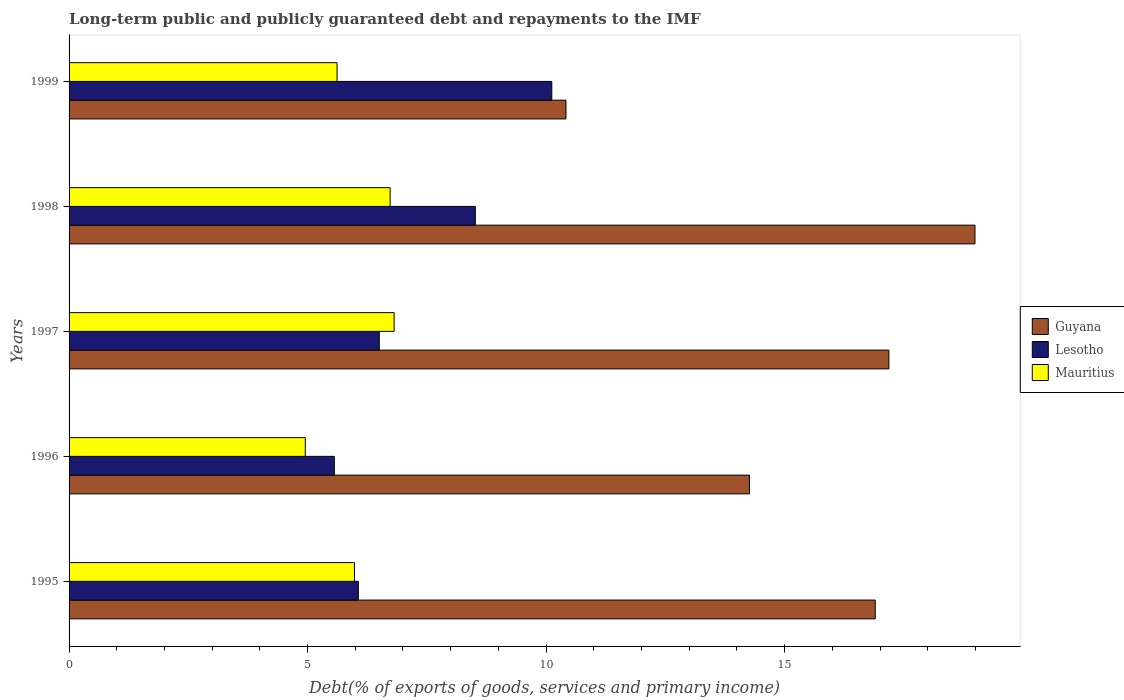How many different coloured bars are there?
Your answer should be very brief. 3. How many groups of bars are there?
Provide a short and direct response. 5. Are the number of bars per tick equal to the number of legend labels?
Your answer should be very brief. Yes. Are the number of bars on each tick of the Y-axis equal?
Make the answer very short. Yes. How many bars are there on the 5th tick from the bottom?
Provide a short and direct response. 3. In how many cases, is the number of bars for a given year not equal to the number of legend labels?
Your answer should be compact. 0. What is the debt and repayments in Guyana in 1999?
Offer a very short reply. 10.42. Across all years, what is the maximum debt and repayments in Guyana?
Your answer should be very brief. 18.99. Across all years, what is the minimum debt and repayments in Lesotho?
Offer a terse response. 5.56. What is the total debt and repayments in Lesotho in the graph?
Your answer should be compact. 36.76. What is the difference between the debt and repayments in Guyana in 1996 and that in 1998?
Ensure brevity in your answer.  -4.73. What is the difference between the debt and repayments in Mauritius in 1995 and the debt and repayments in Guyana in 1998?
Give a very brief answer. -13.01. What is the average debt and repayments in Guyana per year?
Your response must be concise. 15.55. In the year 1997, what is the difference between the debt and repayments in Mauritius and debt and repayments in Guyana?
Offer a very short reply. -10.37. What is the ratio of the debt and repayments in Guyana in 1995 to that in 1999?
Give a very brief answer. 1.62. What is the difference between the highest and the second highest debt and repayments in Lesotho?
Keep it short and to the point. 1.6. What is the difference between the highest and the lowest debt and repayments in Lesotho?
Ensure brevity in your answer.  4.56. Is the sum of the debt and repayments in Mauritius in 1998 and 1999 greater than the maximum debt and repayments in Guyana across all years?
Your answer should be very brief. No. What does the 2nd bar from the top in 1996 represents?
Your answer should be compact. Lesotho. What does the 1st bar from the bottom in 1998 represents?
Offer a terse response. Guyana. Are all the bars in the graph horizontal?
Make the answer very short. Yes. Does the graph contain any zero values?
Your answer should be compact. No. How many legend labels are there?
Give a very brief answer. 3. What is the title of the graph?
Ensure brevity in your answer.  Long-term public and publicly guaranteed debt and repayments to the IMF. Does "Kosovo" appear as one of the legend labels in the graph?
Provide a succinct answer. No. What is the label or title of the X-axis?
Ensure brevity in your answer.  Debt(% of exports of goods, services and primary income). What is the Debt(% of exports of goods, services and primary income) in Guyana in 1995?
Make the answer very short. 16.9. What is the Debt(% of exports of goods, services and primary income) of Lesotho in 1995?
Your response must be concise. 6.06. What is the Debt(% of exports of goods, services and primary income) of Mauritius in 1995?
Offer a terse response. 5.98. What is the Debt(% of exports of goods, services and primary income) in Guyana in 1996?
Give a very brief answer. 14.26. What is the Debt(% of exports of goods, services and primary income) of Lesotho in 1996?
Your response must be concise. 5.56. What is the Debt(% of exports of goods, services and primary income) of Mauritius in 1996?
Keep it short and to the point. 4.95. What is the Debt(% of exports of goods, services and primary income) in Guyana in 1997?
Keep it short and to the point. 17.19. What is the Debt(% of exports of goods, services and primary income) of Lesotho in 1997?
Provide a short and direct response. 6.5. What is the Debt(% of exports of goods, services and primary income) in Mauritius in 1997?
Ensure brevity in your answer.  6.81. What is the Debt(% of exports of goods, services and primary income) in Guyana in 1998?
Give a very brief answer. 18.99. What is the Debt(% of exports of goods, services and primary income) of Lesotho in 1998?
Provide a succinct answer. 8.52. What is the Debt(% of exports of goods, services and primary income) in Mauritius in 1998?
Provide a succinct answer. 6.73. What is the Debt(% of exports of goods, services and primary income) of Guyana in 1999?
Your response must be concise. 10.42. What is the Debt(% of exports of goods, services and primary income) in Lesotho in 1999?
Provide a succinct answer. 10.12. What is the Debt(% of exports of goods, services and primary income) of Mauritius in 1999?
Your answer should be compact. 5.62. Across all years, what is the maximum Debt(% of exports of goods, services and primary income) in Guyana?
Provide a short and direct response. 18.99. Across all years, what is the maximum Debt(% of exports of goods, services and primary income) of Lesotho?
Provide a succinct answer. 10.12. Across all years, what is the maximum Debt(% of exports of goods, services and primary income) in Mauritius?
Provide a short and direct response. 6.81. Across all years, what is the minimum Debt(% of exports of goods, services and primary income) in Guyana?
Offer a terse response. 10.42. Across all years, what is the minimum Debt(% of exports of goods, services and primary income) of Lesotho?
Provide a short and direct response. 5.56. Across all years, what is the minimum Debt(% of exports of goods, services and primary income) of Mauritius?
Give a very brief answer. 4.95. What is the total Debt(% of exports of goods, services and primary income) of Guyana in the graph?
Make the answer very short. 77.76. What is the total Debt(% of exports of goods, services and primary income) in Lesotho in the graph?
Make the answer very short. 36.76. What is the total Debt(% of exports of goods, services and primary income) of Mauritius in the graph?
Your answer should be very brief. 30.1. What is the difference between the Debt(% of exports of goods, services and primary income) of Guyana in 1995 and that in 1996?
Offer a very short reply. 2.64. What is the difference between the Debt(% of exports of goods, services and primary income) of Lesotho in 1995 and that in 1996?
Keep it short and to the point. 0.5. What is the difference between the Debt(% of exports of goods, services and primary income) in Mauritius in 1995 and that in 1996?
Offer a very short reply. 1.03. What is the difference between the Debt(% of exports of goods, services and primary income) of Guyana in 1995 and that in 1997?
Provide a succinct answer. -0.29. What is the difference between the Debt(% of exports of goods, services and primary income) of Lesotho in 1995 and that in 1997?
Make the answer very short. -0.44. What is the difference between the Debt(% of exports of goods, services and primary income) in Mauritius in 1995 and that in 1997?
Your answer should be compact. -0.83. What is the difference between the Debt(% of exports of goods, services and primary income) in Guyana in 1995 and that in 1998?
Keep it short and to the point. -2.09. What is the difference between the Debt(% of exports of goods, services and primary income) of Lesotho in 1995 and that in 1998?
Keep it short and to the point. -2.45. What is the difference between the Debt(% of exports of goods, services and primary income) in Mauritius in 1995 and that in 1998?
Provide a succinct answer. -0.75. What is the difference between the Debt(% of exports of goods, services and primary income) in Guyana in 1995 and that in 1999?
Provide a succinct answer. 6.48. What is the difference between the Debt(% of exports of goods, services and primary income) of Lesotho in 1995 and that in 1999?
Your response must be concise. -4.06. What is the difference between the Debt(% of exports of goods, services and primary income) of Mauritius in 1995 and that in 1999?
Provide a succinct answer. 0.36. What is the difference between the Debt(% of exports of goods, services and primary income) of Guyana in 1996 and that in 1997?
Offer a terse response. -2.92. What is the difference between the Debt(% of exports of goods, services and primary income) of Lesotho in 1996 and that in 1997?
Your answer should be compact. -0.94. What is the difference between the Debt(% of exports of goods, services and primary income) of Mauritius in 1996 and that in 1997?
Make the answer very short. -1.86. What is the difference between the Debt(% of exports of goods, services and primary income) of Guyana in 1996 and that in 1998?
Provide a succinct answer. -4.73. What is the difference between the Debt(% of exports of goods, services and primary income) of Lesotho in 1996 and that in 1998?
Offer a terse response. -2.96. What is the difference between the Debt(% of exports of goods, services and primary income) of Mauritius in 1996 and that in 1998?
Give a very brief answer. -1.78. What is the difference between the Debt(% of exports of goods, services and primary income) in Guyana in 1996 and that in 1999?
Your answer should be very brief. 3.85. What is the difference between the Debt(% of exports of goods, services and primary income) in Lesotho in 1996 and that in 1999?
Keep it short and to the point. -4.56. What is the difference between the Debt(% of exports of goods, services and primary income) in Mauritius in 1996 and that in 1999?
Ensure brevity in your answer.  -0.67. What is the difference between the Debt(% of exports of goods, services and primary income) in Guyana in 1997 and that in 1998?
Your answer should be compact. -1.8. What is the difference between the Debt(% of exports of goods, services and primary income) of Lesotho in 1997 and that in 1998?
Provide a short and direct response. -2.01. What is the difference between the Debt(% of exports of goods, services and primary income) of Mauritius in 1997 and that in 1998?
Ensure brevity in your answer.  0.08. What is the difference between the Debt(% of exports of goods, services and primary income) of Guyana in 1997 and that in 1999?
Make the answer very short. 6.77. What is the difference between the Debt(% of exports of goods, services and primary income) of Lesotho in 1997 and that in 1999?
Provide a succinct answer. -3.62. What is the difference between the Debt(% of exports of goods, services and primary income) in Mauritius in 1997 and that in 1999?
Offer a terse response. 1.2. What is the difference between the Debt(% of exports of goods, services and primary income) in Guyana in 1998 and that in 1999?
Provide a succinct answer. 8.57. What is the difference between the Debt(% of exports of goods, services and primary income) of Lesotho in 1998 and that in 1999?
Provide a short and direct response. -1.6. What is the difference between the Debt(% of exports of goods, services and primary income) of Mauritius in 1998 and that in 1999?
Offer a very short reply. 1.11. What is the difference between the Debt(% of exports of goods, services and primary income) of Guyana in 1995 and the Debt(% of exports of goods, services and primary income) of Lesotho in 1996?
Ensure brevity in your answer.  11.34. What is the difference between the Debt(% of exports of goods, services and primary income) of Guyana in 1995 and the Debt(% of exports of goods, services and primary income) of Mauritius in 1996?
Your answer should be compact. 11.95. What is the difference between the Debt(% of exports of goods, services and primary income) of Lesotho in 1995 and the Debt(% of exports of goods, services and primary income) of Mauritius in 1996?
Make the answer very short. 1.11. What is the difference between the Debt(% of exports of goods, services and primary income) of Guyana in 1995 and the Debt(% of exports of goods, services and primary income) of Lesotho in 1997?
Your answer should be compact. 10.4. What is the difference between the Debt(% of exports of goods, services and primary income) in Guyana in 1995 and the Debt(% of exports of goods, services and primary income) in Mauritius in 1997?
Offer a very short reply. 10.09. What is the difference between the Debt(% of exports of goods, services and primary income) of Lesotho in 1995 and the Debt(% of exports of goods, services and primary income) of Mauritius in 1997?
Your answer should be very brief. -0.75. What is the difference between the Debt(% of exports of goods, services and primary income) of Guyana in 1995 and the Debt(% of exports of goods, services and primary income) of Lesotho in 1998?
Make the answer very short. 8.38. What is the difference between the Debt(% of exports of goods, services and primary income) of Guyana in 1995 and the Debt(% of exports of goods, services and primary income) of Mauritius in 1998?
Offer a terse response. 10.17. What is the difference between the Debt(% of exports of goods, services and primary income) in Guyana in 1995 and the Debt(% of exports of goods, services and primary income) in Lesotho in 1999?
Provide a succinct answer. 6.78. What is the difference between the Debt(% of exports of goods, services and primary income) in Guyana in 1995 and the Debt(% of exports of goods, services and primary income) in Mauritius in 1999?
Give a very brief answer. 11.28. What is the difference between the Debt(% of exports of goods, services and primary income) of Lesotho in 1995 and the Debt(% of exports of goods, services and primary income) of Mauritius in 1999?
Keep it short and to the point. 0.45. What is the difference between the Debt(% of exports of goods, services and primary income) of Guyana in 1996 and the Debt(% of exports of goods, services and primary income) of Lesotho in 1997?
Your answer should be compact. 7.76. What is the difference between the Debt(% of exports of goods, services and primary income) in Guyana in 1996 and the Debt(% of exports of goods, services and primary income) in Mauritius in 1997?
Ensure brevity in your answer.  7.45. What is the difference between the Debt(% of exports of goods, services and primary income) in Lesotho in 1996 and the Debt(% of exports of goods, services and primary income) in Mauritius in 1997?
Make the answer very short. -1.25. What is the difference between the Debt(% of exports of goods, services and primary income) in Guyana in 1996 and the Debt(% of exports of goods, services and primary income) in Lesotho in 1998?
Keep it short and to the point. 5.75. What is the difference between the Debt(% of exports of goods, services and primary income) in Guyana in 1996 and the Debt(% of exports of goods, services and primary income) in Mauritius in 1998?
Ensure brevity in your answer.  7.53. What is the difference between the Debt(% of exports of goods, services and primary income) in Lesotho in 1996 and the Debt(% of exports of goods, services and primary income) in Mauritius in 1998?
Ensure brevity in your answer.  -1.17. What is the difference between the Debt(% of exports of goods, services and primary income) in Guyana in 1996 and the Debt(% of exports of goods, services and primary income) in Lesotho in 1999?
Your response must be concise. 4.14. What is the difference between the Debt(% of exports of goods, services and primary income) of Guyana in 1996 and the Debt(% of exports of goods, services and primary income) of Mauritius in 1999?
Provide a succinct answer. 8.65. What is the difference between the Debt(% of exports of goods, services and primary income) in Lesotho in 1996 and the Debt(% of exports of goods, services and primary income) in Mauritius in 1999?
Provide a succinct answer. -0.06. What is the difference between the Debt(% of exports of goods, services and primary income) in Guyana in 1997 and the Debt(% of exports of goods, services and primary income) in Lesotho in 1998?
Offer a very short reply. 8.67. What is the difference between the Debt(% of exports of goods, services and primary income) in Guyana in 1997 and the Debt(% of exports of goods, services and primary income) in Mauritius in 1998?
Your response must be concise. 10.46. What is the difference between the Debt(% of exports of goods, services and primary income) of Lesotho in 1997 and the Debt(% of exports of goods, services and primary income) of Mauritius in 1998?
Offer a terse response. -0.23. What is the difference between the Debt(% of exports of goods, services and primary income) of Guyana in 1997 and the Debt(% of exports of goods, services and primary income) of Lesotho in 1999?
Give a very brief answer. 7.07. What is the difference between the Debt(% of exports of goods, services and primary income) in Guyana in 1997 and the Debt(% of exports of goods, services and primary income) in Mauritius in 1999?
Keep it short and to the point. 11.57. What is the difference between the Debt(% of exports of goods, services and primary income) of Lesotho in 1997 and the Debt(% of exports of goods, services and primary income) of Mauritius in 1999?
Offer a terse response. 0.89. What is the difference between the Debt(% of exports of goods, services and primary income) in Guyana in 1998 and the Debt(% of exports of goods, services and primary income) in Lesotho in 1999?
Give a very brief answer. 8.87. What is the difference between the Debt(% of exports of goods, services and primary income) of Guyana in 1998 and the Debt(% of exports of goods, services and primary income) of Mauritius in 1999?
Provide a short and direct response. 13.37. What is the difference between the Debt(% of exports of goods, services and primary income) of Lesotho in 1998 and the Debt(% of exports of goods, services and primary income) of Mauritius in 1999?
Provide a short and direct response. 2.9. What is the average Debt(% of exports of goods, services and primary income) in Guyana per year?
Your response must be concise. 15.55. What is the average Debt(% of exports of goods, services and primary income) of Lesotho per year?
Provide a succinct answer. 7.35. What is the average Debt(% of exports of goods, services and primary income) of Mauritius per year?
Ensure brevity in your answer.  6.02. In the year 1995, what is the difference between the Debt(% of exports of goods, services and primary income) of Guyana and Debt(% of exports of goods, services and primary income) of Lesotho?
Provide a succinct answer. 10.84. In the year 1995, what is the difference between the Debt(% of exports of goods, services and primary income) in Guyana and Debt(% of exports of goods, services and primary income) in Mauritius?
Your response must be concise. 10.92. In the year 1995, what is the difference between the Debt(% of exports of goods, services and primary income) of Lesotho and Debt(% of exports of goods, services and primary income) of Mauritius?
Ensure brevity in your answer.  0.08. In the year 1996, what is the difference between the Debt(% of exports of goods, services and primary income) in Guyana and Debt(% of exports of goods, services and primary income) in Lesotho?
Your answer should be very brief. 8.7. In the year 1996, what is the difference between the Debt(% of exports of goods, services and primary income) of Guyana and Debt(% of exports of goods, services and primary income) of Mauritius?
Keep it short and to the point. 9.31. In the year 1996, what is the difference between the Debt(% of exports of goods, services and primary income) in Lesotho and Debt(% of exports of goods, services and primary income) in Mauritius?
Your response must be concise. 0.61. In the year 1997, what is the difference between the Debt(% of exports of goods, services and primary income) in Guyana and Debt(% of exports of goods, services and primary income) in Lesotho?
Provide a succinct answer. 10.68. In the year 1997, what is the difference between the Debt(% of exports of goods, services and primary income) of Guyana and Debt(% of exports of goods, services and primary income) of Mauritius?
Provide a short and direct response. 10.37. In the year 1997, what is the difference between the Debt(% of exports of goods, services and primary income) of Lesotho and Debt(% of exports of goods, services and primary income) of Mauritius?
Your answer should be very brief. -0.31. In the year 1998, what is the difference between the Debt(% of exports of goods, services and primary income) of Guyana and Debt(% of exports of goods, services and primary income) of Lesotho?
Give a very brief answer. 10.47. In the year 1998, what is the difference between the Debt(% of exports of goods, services and primary income) of Guyana and Debt(% of exports of goods, services and primary income) of Mauritius?
Ensure brevity in your answer.  12.26. In the year 1998, what is the difference between the Debt(% of exports of goods, services and primary income) of Lesotho and Debt(% of exports of goods, services and primary income) of Mauritius?
Make the answer very short. 1.79. In the year 1999, what is the difference between the Debt(% of exports of goods, services and primary income) in Guyana and Debt(% of exports of goods, services and primary income) in Lesotho?
Ensure brevity in your answer.  0.3. In the year 1999, what is the difference between the Debt(% of exports of goods, services and primary income) in Guyana and Debt(% of exports of goods, services and primary income) in Mauritius?
Your answer should be compact. 4.8. In the year 1999, what is the difference between the Debt(% of exports of goods, services and primary income) in Lesotho and Debt(% of exports of goods, services and primary income) in Mauritius?
Ensure brevity in your answer.  4.5. What is the ratio of the Debt(% of exports of goods, services and primary income) in Guyana in 1995 to that in 1996?
Provide a succinct answer. 1.18. What is the ratio of the Debt(% of exports of goods, services and primary income) of Lesotho in 1995 to that in 1996?
Keep it short and to the point. 1.09. What is the ratio of the Debt(% of exports of goods, services and primary income) in Mauritius in 1995 to that in 1996?
Your answer should be very brief. 1.21. What is the ratio of the Debt(% of exports of goods, services and primary income) in Guyana in 1995 to that in 1997?
Your answer should be compact. 0.98. What is the ratio of the Debt(% of exports of goods, services and primary income) in Lesotho in 1995 to that in 1997?
Give a very brief answer. 0.93. What is the ratio of the Debt(% of exports of goods, services and primary income) in Mauritius in 1995 to that in 1997?
Give a very brief answer. 0.88. What is the ratio of the Debt(% of exports of goods, services and primary income) in Guyana in 1995 to that in 1998?
Ensure brevity in your answer.  0.89. What is the ratio of the Debt(% of exports of goods, services and primary income) in Lesotho in 1995 to that in 1998?
Ensure brevity in your answer.  0.71. What is the ratio of the Debt(% of exports of goods, services and primary income) of Mauritius in 1995 to that in 1998?
Provide a short and direct response. 0.89. What is the ratio of the Debt(% of exports of goods, services and primary income) of Guyana in 1995 to that in 1999?
Provide a succinct answer. 1.62. What is the ratio of the Debt(% of exports of goods, services and primary income) in Lesotho in 1995 to that in 1999?
Your answer should be very brief. 0.6. What is the ratio of the Debt(% of exports of goods, services and primary income) of Mauritius in 1995 to that in 1999?
Keep it short and to the point. 1.06. What is the ratio of the Debt(% of exports of goods, services and primary income) of Guyana in 1996 to that in 1997?
Keep it short and to the point. 0.83. What is the ratio of the Debt(% of exports of goods, services and primary income) of Lesotho in 1996 to that in 1997?
Offer a very short reply. 0.85. What is the ratio of the Debt(% of exports of goods, services and primary income) in Mauritius in 1996 to that in 1997?
Give a very brief answer. 0.73. What is the ratio of the Debt(% of exports of goods, services and primary income) of Guyana in 1996 to that in 1998?
Keep it short and to the point. 0.75. What is the ratio of the Debt(% of exports of goods, services and primary income) of Lesotho in 1996 to that in 1998?
Keep it short and to the point. 0.65. What is the ratio of the Debt(% of exports of goods, services and primary income) of Mauritius in 1996 to that in 1998?
Provide a succinct answer. 0.74. What is the ratio of the Debt(% of exports of goods, services and primary income) of Guyana in 1996 to that in 1999?
Offer a very short reply. 1.37. What is the ratio of the Debt(% of exports of goods, services and primary income) of Lesotho in 1996 to that in 1999?
Provide a short and direct response. 0.55. What is the ratio of the Debt(% of exports of goods, services and primary income) in Mauritius in 1996 to that in 1999?
Make the answer very short. 0.88. What is the ratio of the Debt(% of exports of goods, services and primary income) of Guyana in 1997 to that in 1998?
Offer a terse response. 0.91. What is the ratio of the Debt(% of exports of goods, services and primary income) in Lesotho in 1997 to that in 1998?
Your answer should be very brief. 0.76. What is the ratio of the Debt(% of exports of goods, services and primary income) of Mauritius in 1997 to that in 1998?
Ensure brevity in your answer.  1.01. What is the ratio of the Debt(% of exports of goods, services and primary income) in Guyana in 1997 to that in 1999?
Your response must be concise. 1.65. What is the ratio of the Debt(% of exports of goods, services and primary income) of Lesotho in 1997 to that in 1999?
Give a very brief answer. 0.64. What is the ratio of the Debt(% of exports of goods, services and primary income) of Mauritius in 1997 to that in 1999?
Your answer should be very brief. 1.21. What is the ratio of the Debt(% of exports of goods, services and primary income) in Guyana in 1998 to that in 1999?
Provide a short and direct response. 1.82. What is the ratio of the Debt(% of exports of goods, services and primary income) of Lesotho in 1998 to that in 1999?
Your answer should be compact. 0.84. What is the ratio of the Debt(% of exports of goods, services and primary income) in Mauritius in 1998 to that in 1999?
Your response must be concise. 1.2. What is the difference between the highest and the second highest Debt(% of exports of goods, services and primary income) of Guyana?
Offer a terse response. 1.8. What is the difference between the highest and the second highest Debt(% of exports of goods, services and primary income) of Lesotho?
Offer a very short reply. 1.6. What is the difference between the highest and the second highest Debt(% of exports of goods, services and primary income) in Mauritius?
Your response must be concise. 0.08. What is the difference between the highest and the lowest Debt(% of exports of goods, services and primary income) in Guyana?
Your answer should be compact. 8.57. What is the difference between the highest and the lowest Debt(% of exports of goods, services and primary income) of Lesotho?
Your answer should be very brief. 4.56. What is the difference between the highest and the lowest Debt(% of exports of goods, services and primary income) in Mauritius?
Provide a succinct answer. 1.86. 